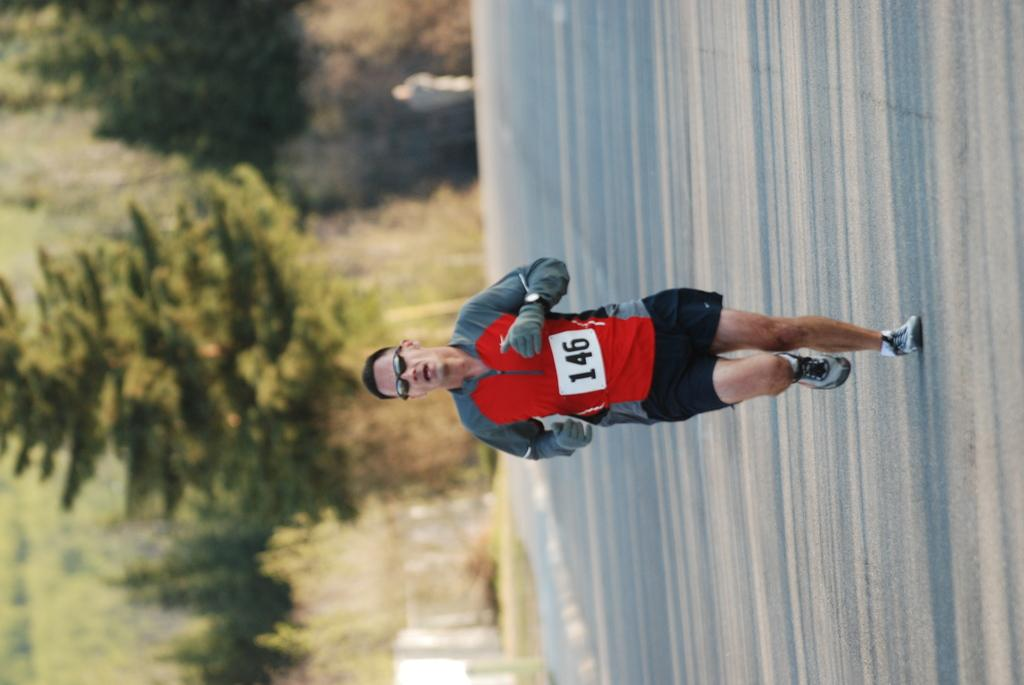What is the main action being performed by the person in the image? There is a person running in the center of the image. What can be seen on the left side of the image? There is a road on the left side of the image. What is visible in the background of the image? There are trees and plants in the background of the image. What type of hand is holding the chain in the image? There is no hand or chain present in the image. 